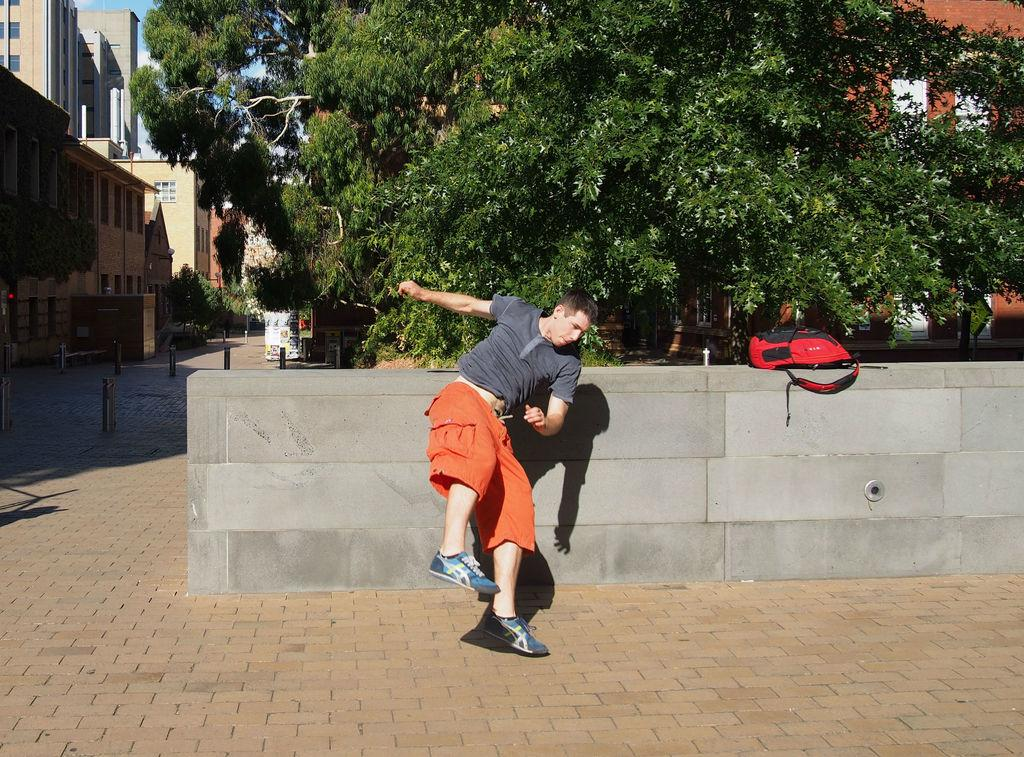What is the main subject in the image? There is a man standing in the image. What object is present near the man? There is a bag in the image. What type of structures can be seen in the image? There are buildings in the image. What type of vegetation is visible in the image? There are trees in the image. What type of gun is the man holding in the image? There is no gun present in the image; the man is not holding any weapon. What type of pet is visible near the man in the image? There is no pet present in the image; only the man, the bag, buildings, and trees are visible. 